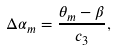<formula> <loc_0><loc_0><loc_500><loc_500>\Delta \alpha _ { m } = \frac { \theta _ { m } - \beta } { c _ { 3 } } ,</formula> 